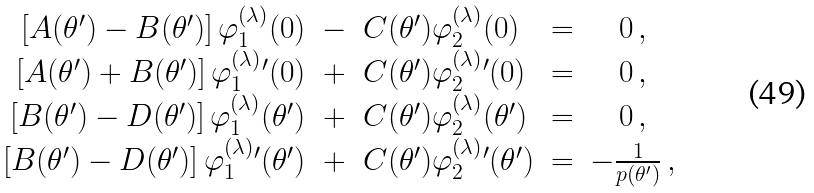<formula> <loc_0><loc_0><loc_500><loc_500>\begin{array} { r c l c c } \left [ A ( \theta ^ { \prime } ) - B ( \theta ^ { \prime } ) \right ] \varphi _ { 1 } ^ { ( \lambda ) } ( 0 ) & - & C ( \theta ^ { \prime } ) \varphi _ { 2 } ^ { ( \lambda ) } ( 0 ) & = & 0 \, , \\ \left [ A ( \theta ^ { \prime } ) + B ( \theta ^ { \prime } ) \right ] { \varphi _ { 1 } ^ { ( \lambda ) } } { ^ { \prime } } ( 0 ) & + & C ( \theta ^ { \prime } ) { \varphi _ { 2 } ^ { ( \lambda ) } } { ^ { \prime } } ( 0 ) & = & 0 \, , \\ \left [ B ( \theta ^ { \prime } ) - D ( \theta ^ { \prime } ) \right ] \varphi _ { 1 } ^ { ( \lambda ) } ( \theta ^ { \prime } ) & + & C ( \theta ^ { \prime } ) \varphi _ { 2 } ^ { ( \lambda ) } ( \theta ^ { \prime } ) & = & 0 \, , \\ \left [ B ( \theta ^ { \prime } ) - D ( \theta ^ { \prime } ) \right ] { \varphi _ { 1 } ^ { ( \lambda ) } } { ^ { \prime } } ( \theta ^ { \prime } ) & + & C ( \theta ^ { \prime } ) { \varphi _ { 2 } ^ { ( \lambda ) } } { ^ { \prime } } ( \theta ^ { \prime } ) & = & - \frac { 1 } { p ( \theta ^ { \prime } ) } \, , \end{array}</formula> 